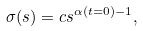Convert formula to latex. <formula><loc_0><loc_0><loc_500><loc_500>\sigma ( s ) = c s ^ { \alpha ( t = 0 ) - 1 } ,</formula> 